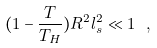<formula> <loc_0><loc_0><loc_500><loc_500>( 1 - \frac { T } { T _ { H } } ) R ^ { 2 } l _ { s } ^ { 2 } \ll 1 \ ,</formula> 